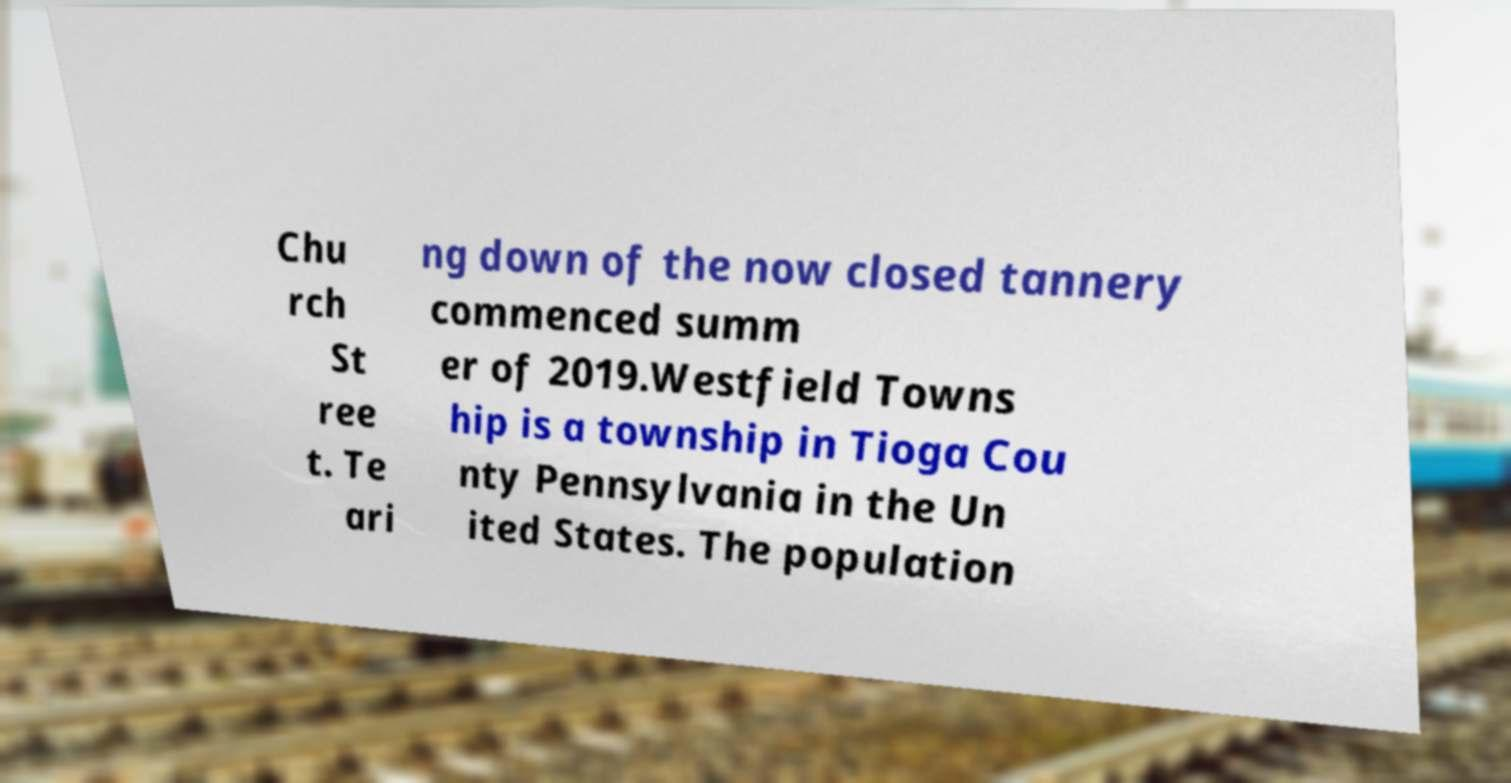Can you accurately transcribe the text from the provided image for me? Chu rch St ree t. Te ari ng down of the now closed tannery commenced summ er of 2019.Westfield Towns hip is a township in Tioga Cou nty Pennsylvania in the Un ited States. The population 